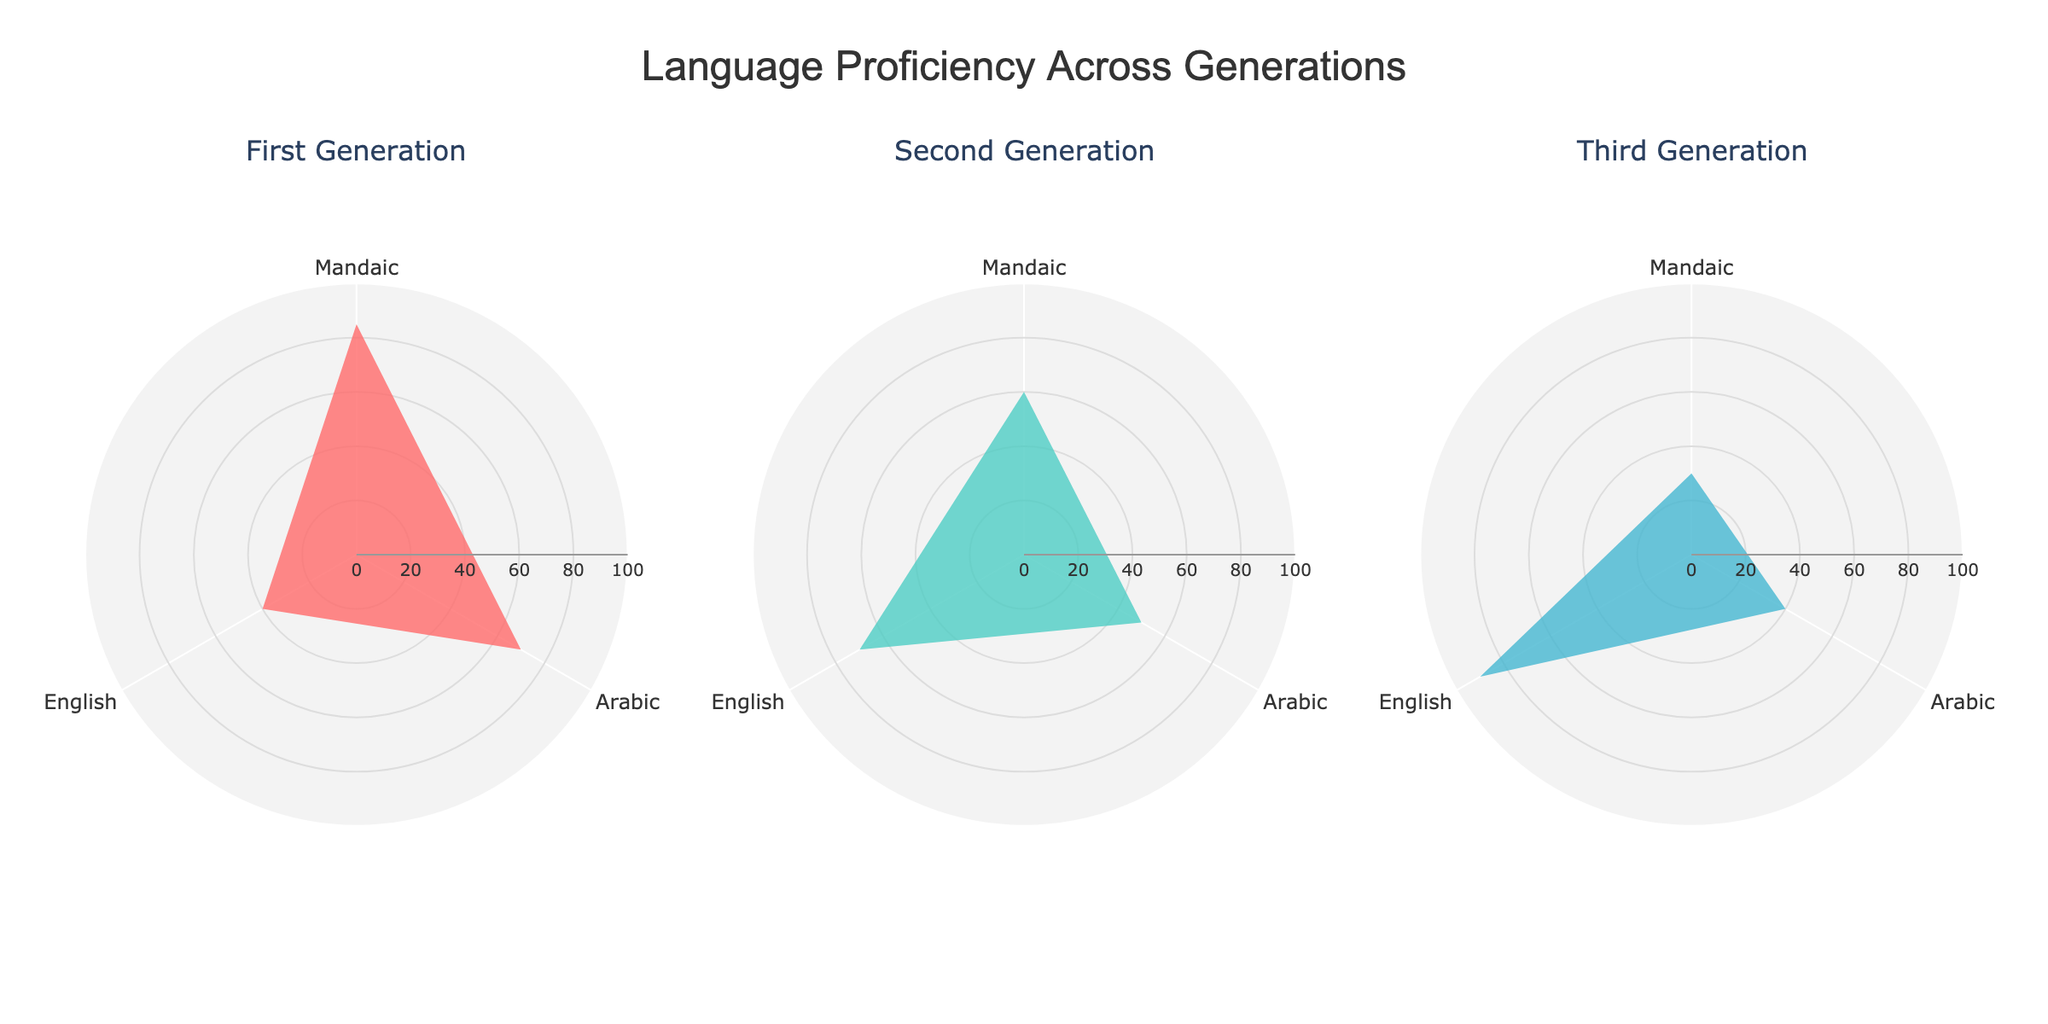What is the title of the figure? The title is placed at the top center of the figure. It reads "Language Proficiency Across Generations".
Answer: Language Proficiency Across Generations Which generation has the highest proficiency in English? By looking at the subplot for each generation, we can see that the proficiency in English increases from the first generation to the third generation. The third generation shows the highest proficiency at 90.
Answer: Third Generation What is the proficiency difference in Mandaic between the First and Third Generations? The proficiency in Mandaic for the First Generation is 85 and for the Third Generation is 30. The difference is calculated as 85 - 30.
Answer: 55 How many generations are shown in the figure? The figure contains three subplots, each titled with a different generation. By counting these titles, we find there are three generations shown.
Answer: 3 Between which two languages is there the smallest proficiency difference in the Second Generation? For the Second Generation, Mandaic has a proficiency of 60, Arabic 50, and English 70. The smallest differences are between Mandaic and Arabic (60-50) and Arabic and English (70-50). Calculating these, 60-50 is the smallest difference of 10.
Answer: Mandaic and Arabic Which language shows a declining proficiency trend across the Generations? By observing the proficiency values across all three subplots, Mandaic proficiency decreases from 85 in the First Generation to 60 in the Second Generation to 30 in the Third Generation.
Answer: Mandaic What type of chart is used for each generation in the figure? Each subplot uses a rose chart (also known as a polar area chart) to represent the language proficiency data, featuring circular sectors.
Answer: Rose chart Compare the English proficiency of the First Generation to the Third Generation. What do you observe? The First Generation shows a proficiency of 40 in English, while the Third Generation shows a proficiency of 90. The Third Generation is more proficient in English, with a notable increase of 50.
Answer: Third Generation is higher What is the average proficiency in Arabic across all generations? The proficiency values for Arabic are 70 for the First Generation, 50 for the Second Generation, and 40 for the Third Generation. Calculating the average: (70 + 50 + 40) / 3.
Answer: 53.33 Which generation has the least proficiency in Mandaic? Looking at the proficiency values for Mandaic across the subplots, we see that the Third Generation has the lowest proficiency at 30.
Answer: Third Generation 